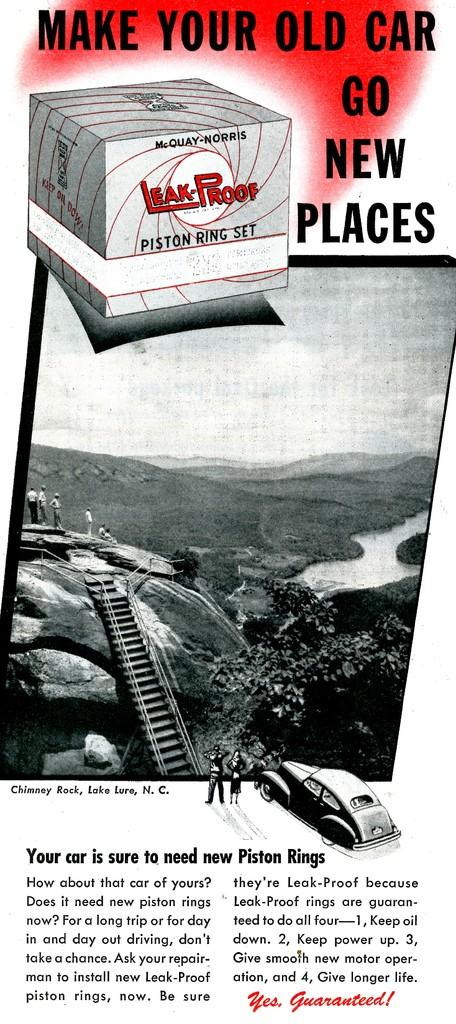<image>
Give a short and clear explanation of the subsequent image. An ad for a Leak-Proof piston ring set. 